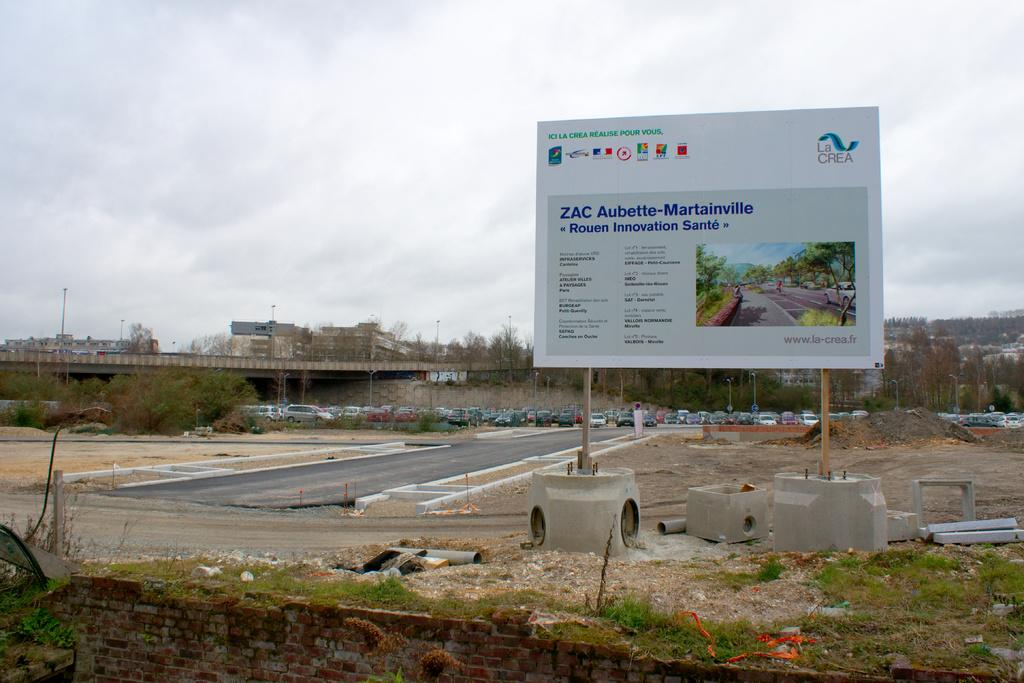<image>
Write a terse but informative summary of the picture. A big white sign that says ZAC on a construction site. 